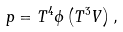<formula> <loc_0><loc_0><loc_500><loc_500>p = T ^ { 4 } \phi \left ( T ^ { 3 } V \right ) ,</formula> 